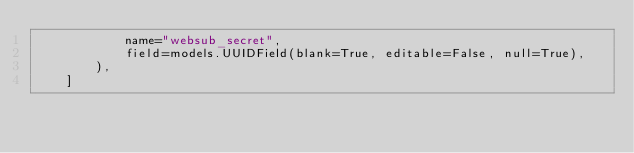Convert code to text. <code><loc_0><loc_0><loc_500><loc_500><_Python_>            name="websub_secret",
            field=models.UUIDField(blank=True, editable=False, null=True),
        ),
    ]
</code> 